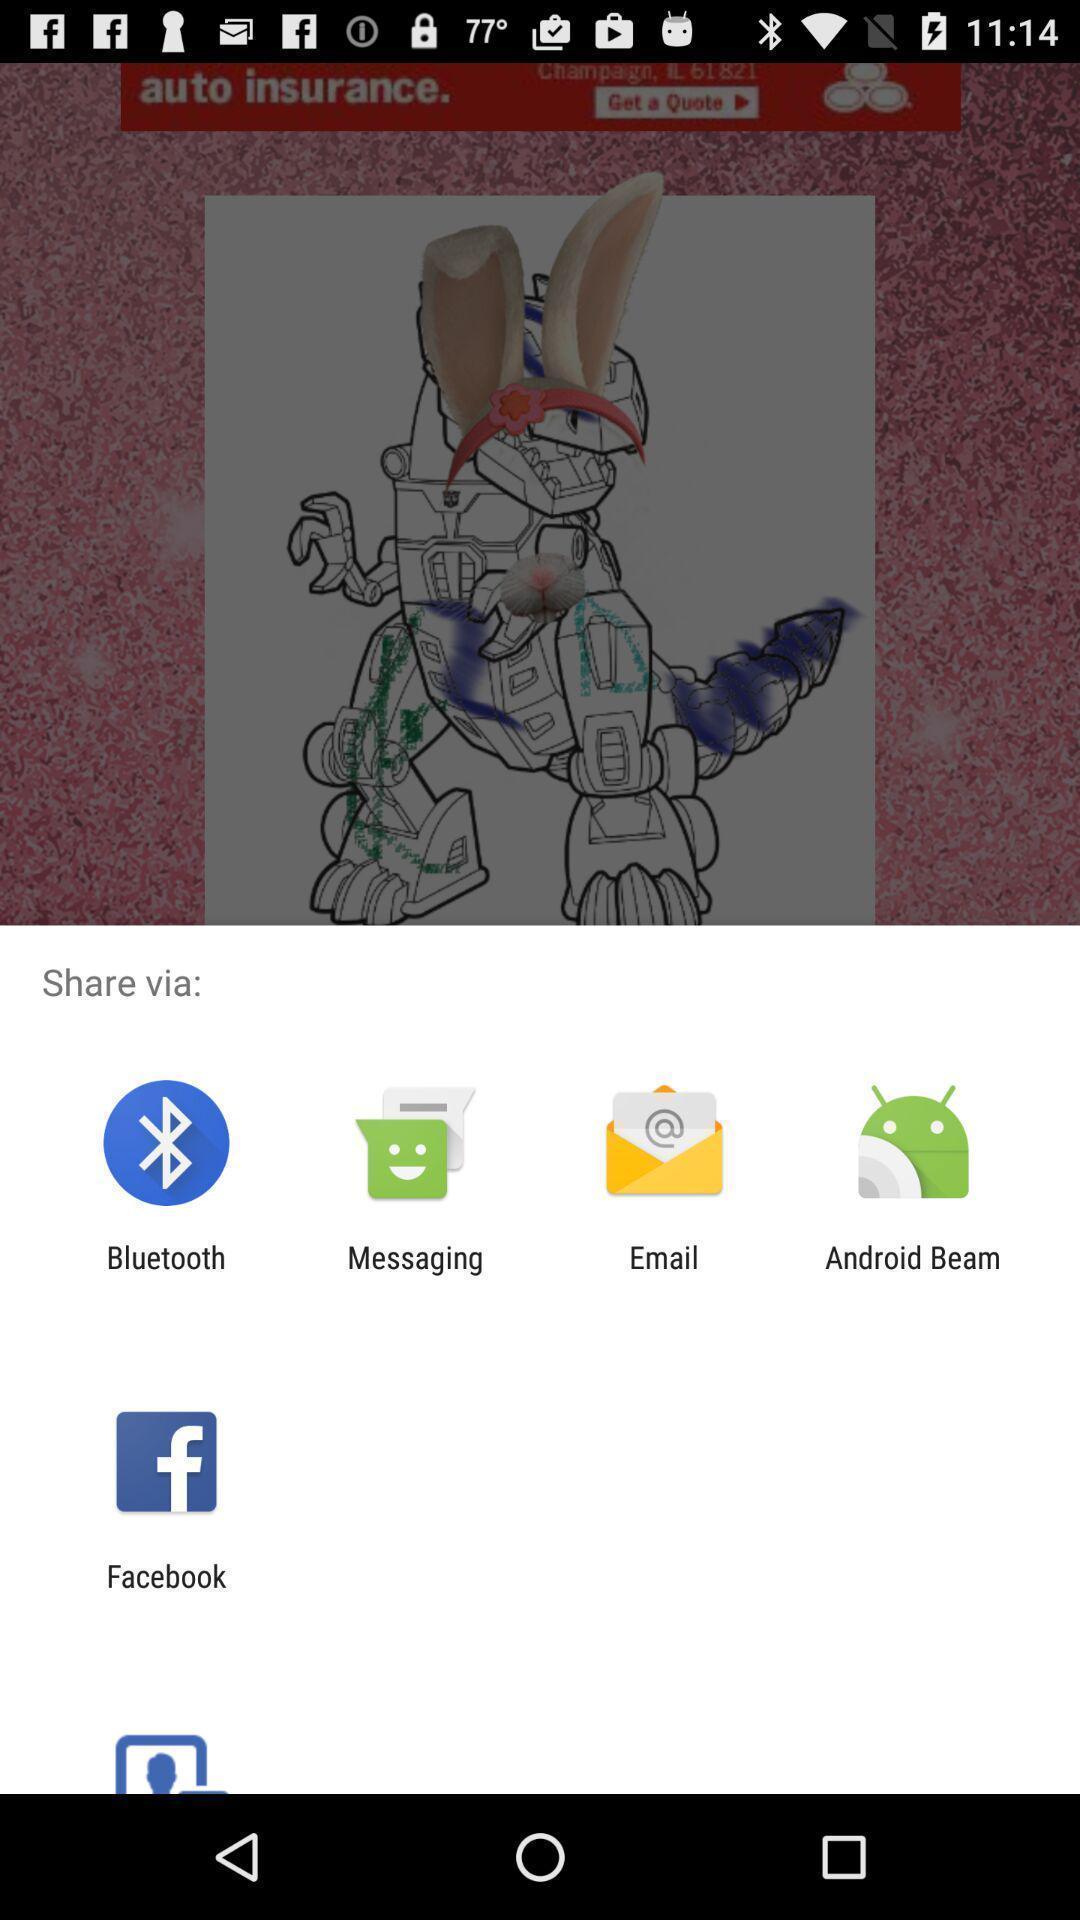Summarize the main components in this picture. Screen displaying to share via with different apps. 